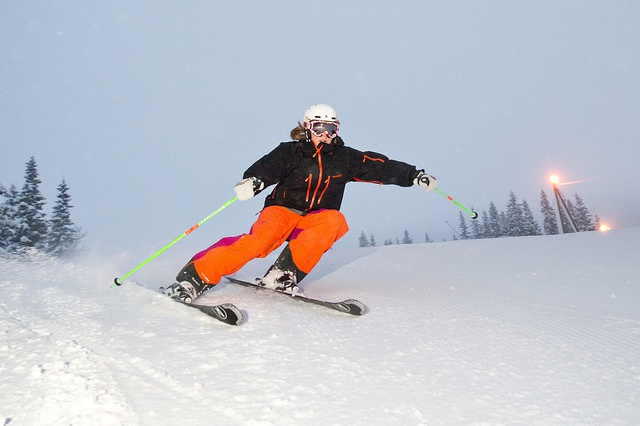Describe the objects in this image and their specific colors. I can see people in lightblue, black, red, and lightgray tones and skis in lightblue, gray, darkgray, and lightgray tones in this image. 